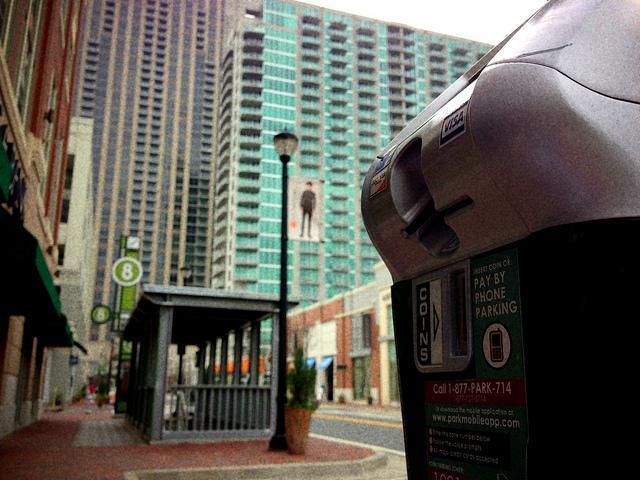How many giraffes are in this picture?
Give a very brief answer. 0. 